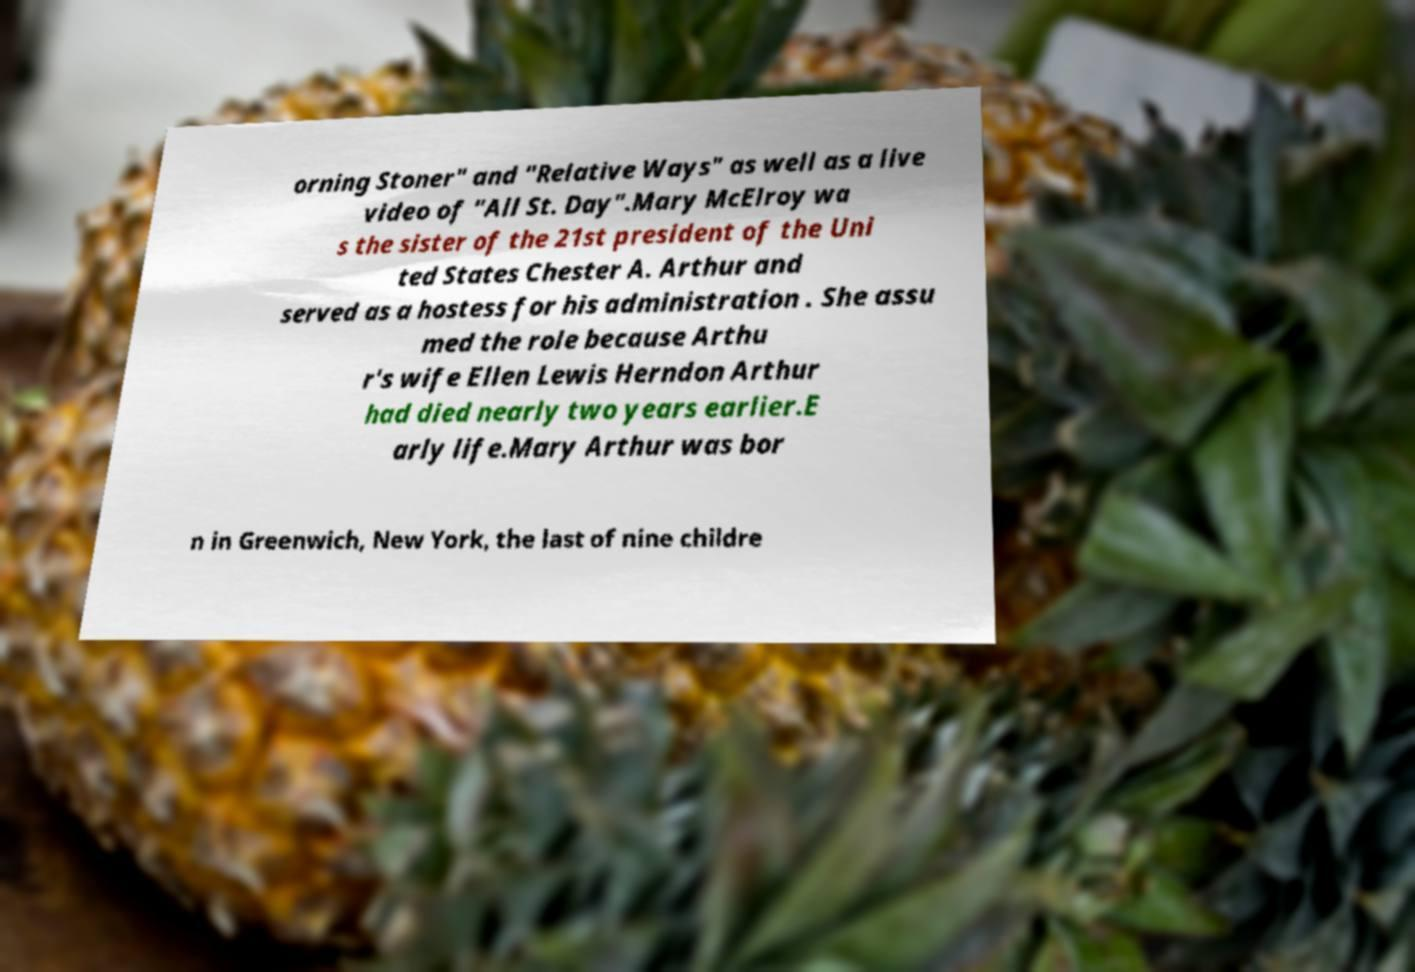Please identify and transcribe the text found in this image. orning Stoner" and "Relative Ways" as well as a live video of "All St. Day".Mary McElroy wa s the sister of the 21st president of the Uni ted States Chester A. Arthur and served as a hostess for his administration . She assu med the role because Arthu r's wife Ellen Lewis Herndon Arthur had died nearly two years earlier.E arly life.Mary Arthur was bor n in Greenwich, New York, the last of nine childre 